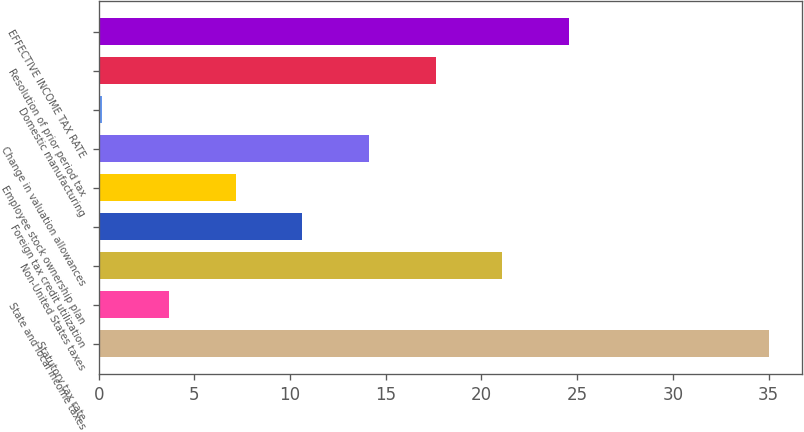Convert chart. <chart><loc_0><loc_0><loc_500><loc_500><bar_chart><fcel>Statutory tax rate<fcel>State and local income taxes<fcel>Non-United States taxes<fcel>Foreign tax credit utilization<fcel>Employee stock ownership plan<fcel>Change in valuation allowances<fcel>Domestic manufacturing<fcel>Resolution of prior period tax<fcel>EFFECTIVE INCOME TAX RATE<nl><fcel>35<fcel>3.68<fcel>21.08<fcel>10.64<fcel>7.16<fcel>14.12<fcel>0.2<fcel>17.6<fcel>24.56<nl></chart> 